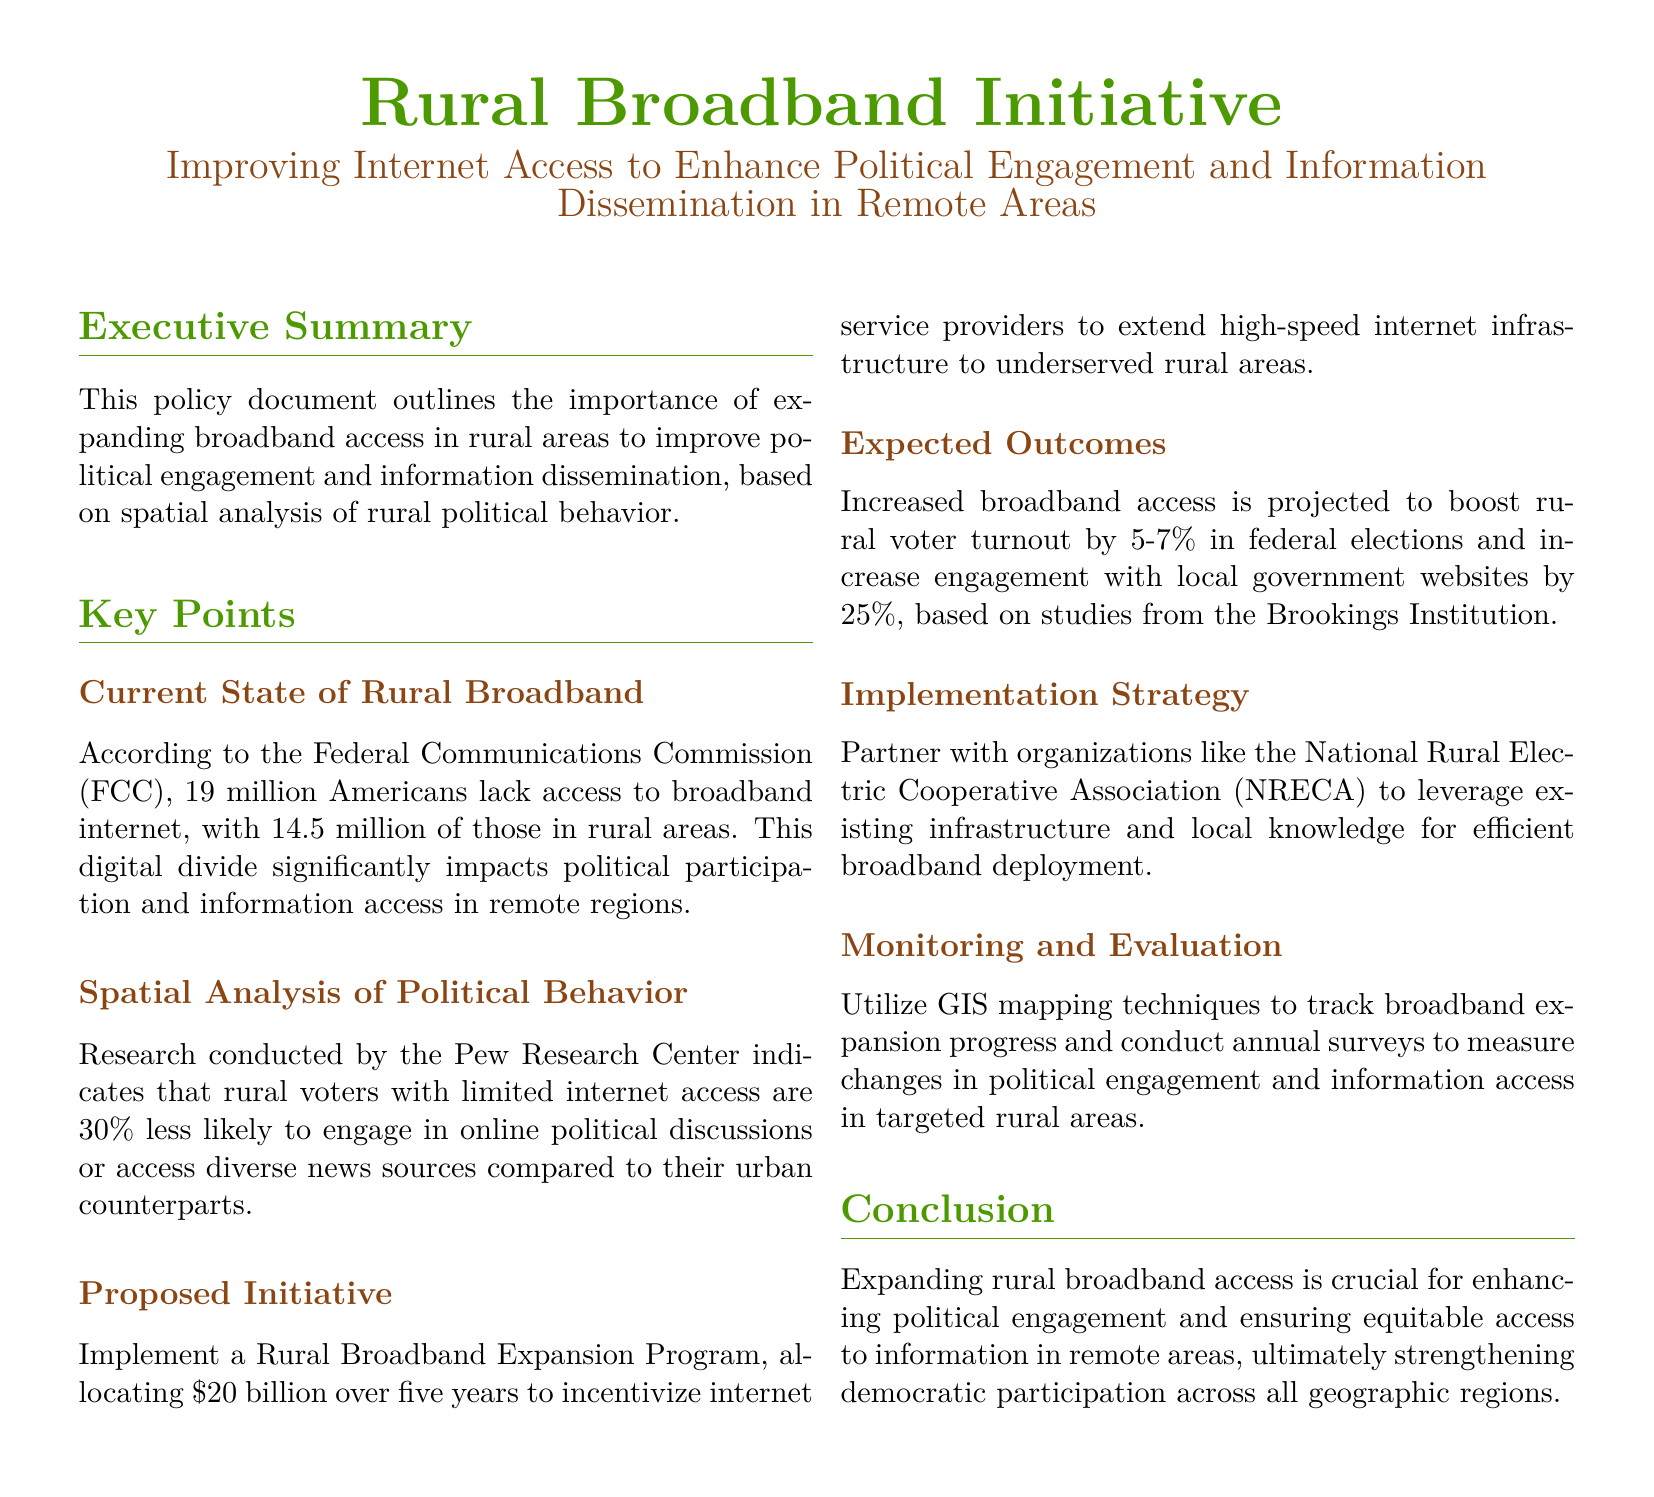What percentage of rural voters are less likely to engage in online discussions? The document states that rural voters with limited internet access are 30% less likely to engage in online political discussions compared to their urban counterparts.
Answer: 30% How much funding is proposed for the Rural Broadband Expansion Program? The proposed funding allocation for the Rural Broadband Expansion Program is mentioned in the document as $20 billion.
Answer: $20 billion What is the expected increase in rural voter turnout in federal elections? The expected increase in rural voter turnout as a result of this initiative is projected to be between 5-7%.
Answer: 5-7% Which organization is suggested for partnership in the implementation strategy? The document suggests partnering with the National Rural Electric Cooperative Association (NRECA) for efficient broadband deployment.
Answer: National Rural Electric Cooperative Association What is the main goal of the Rural Broadband Initiative? The main goal outlined in the document is to enhance political engagement and information dissemination in remote areas through improved internet access.
Answer: Enhance political engagement What technique is recommended for monitoring and evaluation? The recommended technique for monitoring and evaluation in the document is GIS mapping.
Answer: GIS mapping How many Americans lack access to broadband according to the FCC? The document cites that 19 million Americans lack access to broadband internet.
Answer: 19 million What impact does limited internet access have on rural voters according to the Pew Research Center? Limited internet access leads to rural voters being 30% less likely to engage in online political discussions or access diverse news sources compared to urban voters.
Answer: 30% less likely 